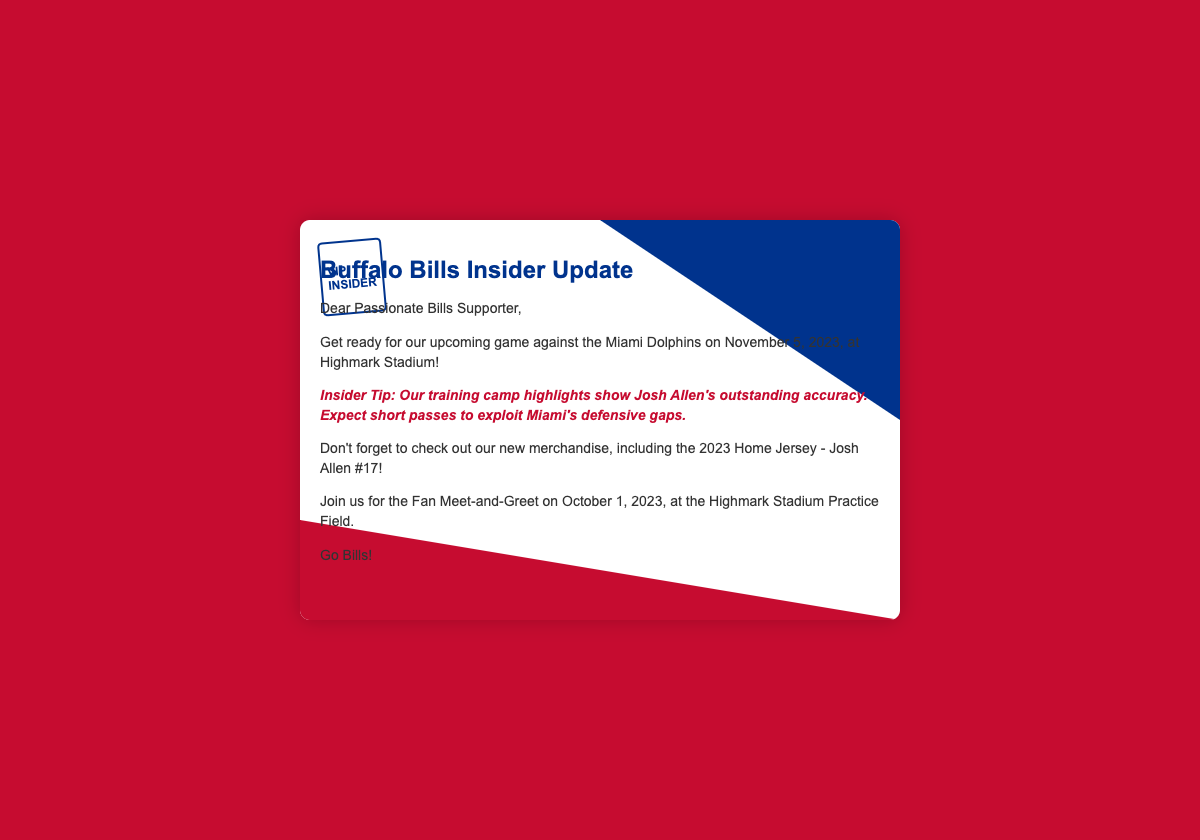what is the date of the game against the Miami Dolphins? The game against the Miami Dolphins is scheduled for November 5, 2023.
Answer: November 5, 2023 what is the location of the upcoming game? The location of the game is Highmark Stadium.
Answer: Highmark Stadium which player is highlighted in the new merchandise? The player highlighted in the new merchandise is Josh Allen.
Answer: Josh Allen what type of event is scheduled for October 1, 2023? The event scheduled for October 1, 2023, is a Fan Meet-and-Greet.
Answer: Fan Meet-and-Greet what is a key strength mentioned for Josh Allen? A key strength mentioned for Josh Allen is his outstanding accuracy.
Answer: outstanding accuracy what is an expected strategy against Miami's defense? The expected strategy is to exploit Miami's defensive gaps with short passes.
Answer: short passes what color is the envelope background? The envelope background color is red.
Answer: red what is the content type of this document? This document is an insider update for Buffalo Bills supporters.
Answer: insider update 